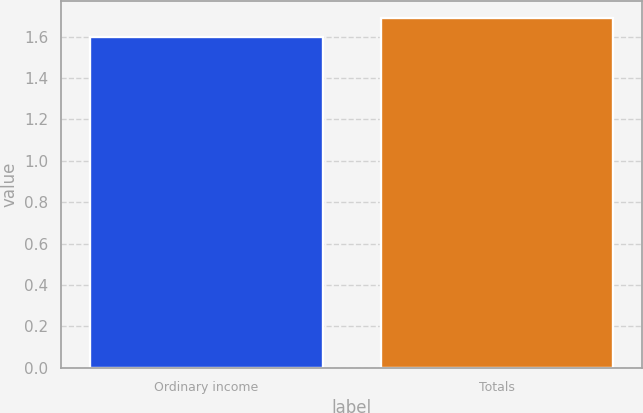Convert chart. <chart><loc_0><loc_0><loc_500><loc_500><bar_chart><fcel>Ordinary income<fcel>Totals<nl><fcel>1.6<fcel>1.69<nl></chart> 